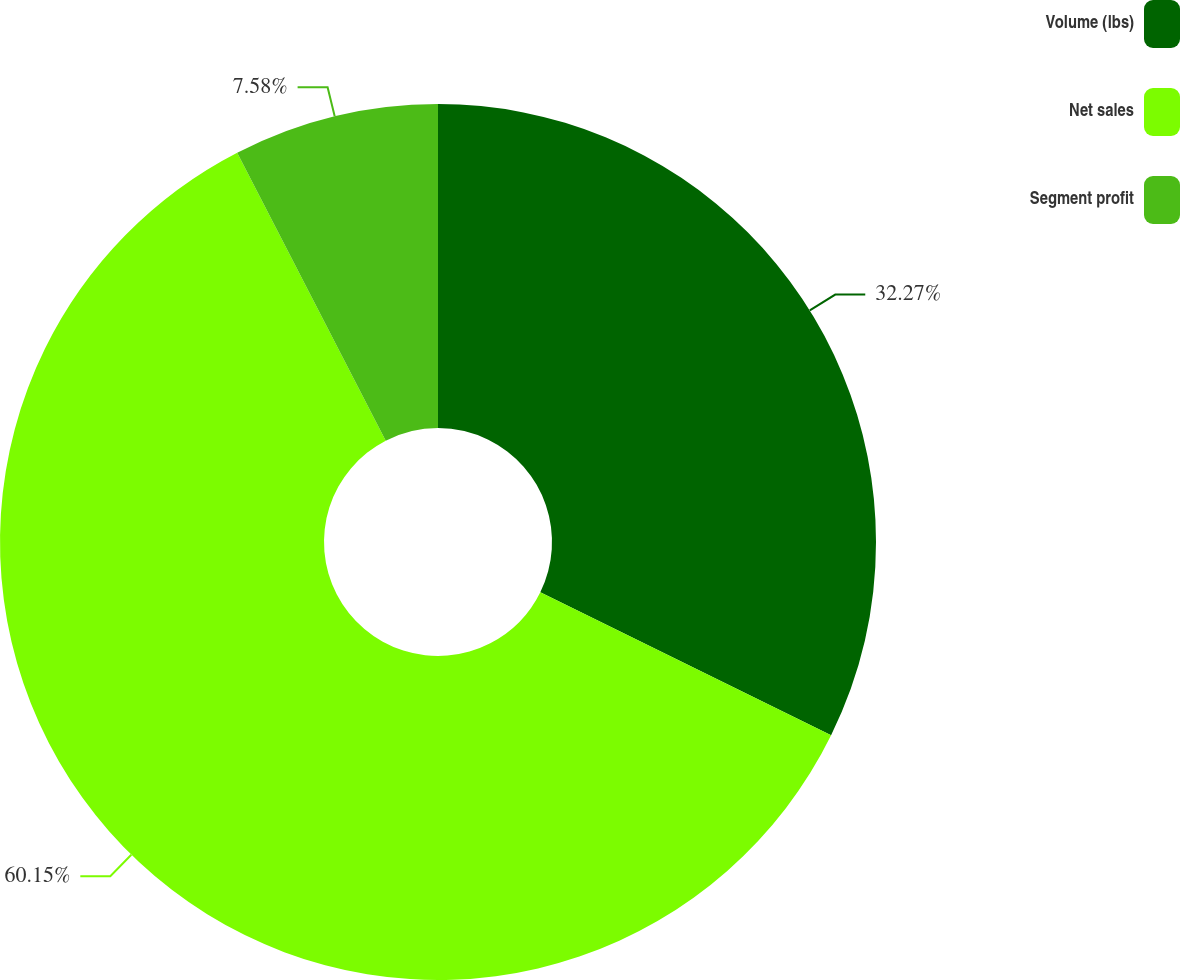Convert chart. <chart><loc_0><loc_0><loc_500><loc_500><pie_chart><fcel>Volume (lbs)<fcel>Net sales<fcel>Segment profit<nl><fcel>32.27%<fcel>60.15%<fcel>7.58%<nl></chart> 